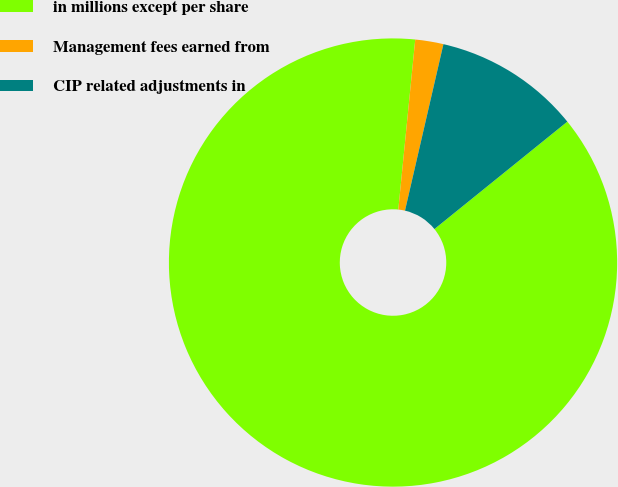Convert chart. <chart><loc_0><loc_0><loc_500><loc_500><pie_chart><fcel>in millions except per share<fcel>Management fees earned from<fcel>CIP related adjustments in<nl><fcel>87.4%<fcel>2.03%<fcel>10.57%<nl></chart> 